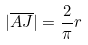<formula> <loc_0><loc_0><loc_500><loc_500>| \overline { A J } | = \frac { 2 } { \pi } r</formula> 